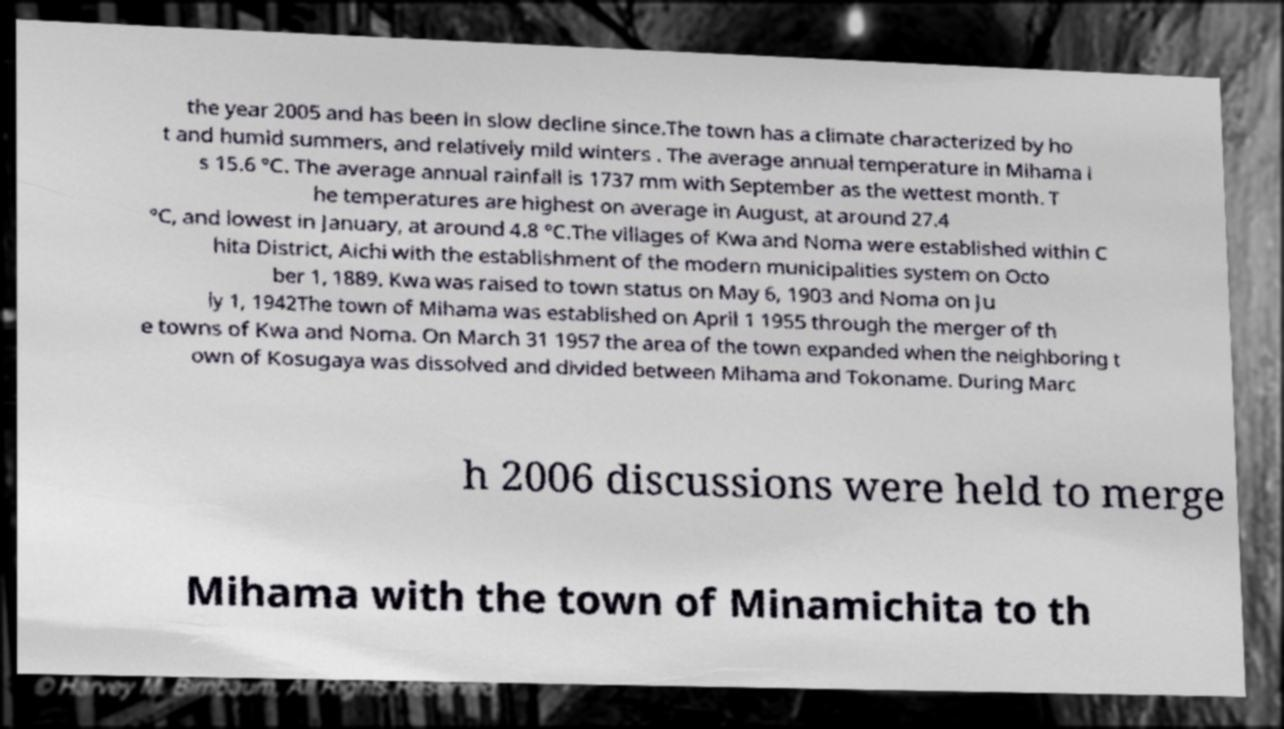There's text embedded in this image that I need extracted. Can you transcribe it verbatim? the year 2005 and has been in slow decline since.The town has a climate characterized by ho t and humid summers, and relatively mild winters . The average annual temperature in Mihama i s 15.6 °C. The average annual rainfall is 1737 mm with September as the wettest month. T he temperatures are highest on average in August, at around 27.4 °C, and lowest in January, at around 4.8 °C.The villages of Kwa and Noma were established within C hita District, Aichi with the establishment of the modern municipalities system on Octo ber 1, 1889. Kwa was raised to town status on May 6, 1903 and Noma on Ju ly 1, 1942The town of Mihama was established on April 1 1955 through the merger of th e towns of Kwa and Noma. On March 31 1957 the area of the town expanded when the neighboring t own of Kosugaya was dissolved and divided between Mihama and Tokoname. During Marc h 2006 discussions were held to merge Mihama with the town of Minamichita to th 